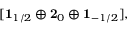<formula> <loc_0><loc_0><loc_500><loc_500>[ { 1 } _ { 1 / 2 } \oplus { 2 } _ { 0 } \oplus { 1 } _ { - 1 / 2 } ] ,</formula> 